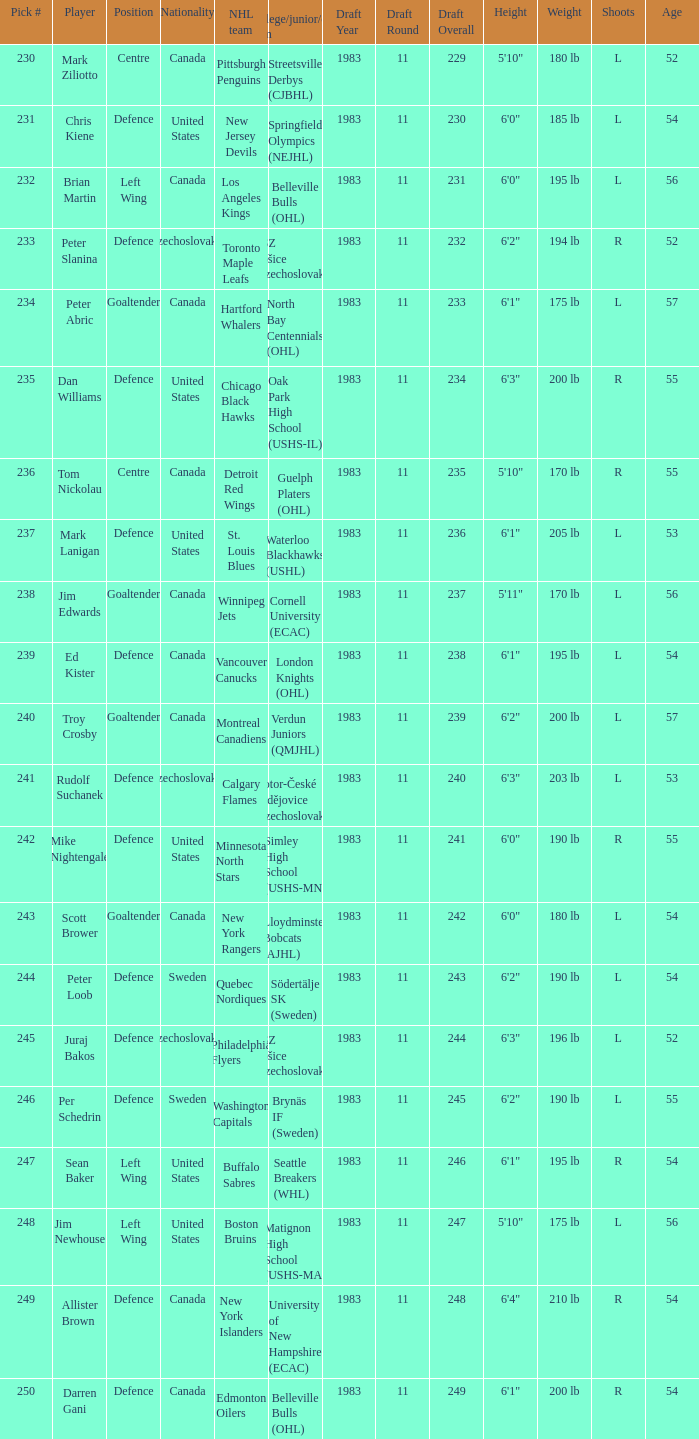To which organziation does the  winnipeg jets belong to? Cornell University (ECAC). 